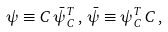<formula> <loc_0><loc_0><loc_500><loc_500>\psi \equiv C \, \bar { \psi } _ { C } ^ { T } \, , \, \bar { \psi } \equiv \psi _ { C } ^ { T } \, C \, ,</formula> 